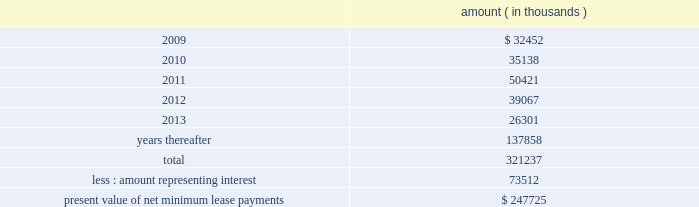Entergy corporation and subsidiaries notes to financial statements computed on a rolling 12 month basis .
As of december 31 , 2008 , entergy louisiana was in compliance with these provisions .
As of december 31 , 2008 , entergy louisiana had future minimum lease payments ( reflecting an overall implicit rate of 7.45% ( 7.45 % ) ) in connection with the waterford 3 sale and leaseback transactions , which are recorded as long-term debt , as follows : amount ( in thousands ) .
Grand gulf lease obligations in december 1988 , in two separate but substantially identical transactions , system energy sold and leased back undivided ownership interests in grand gulf for the aggregate sum of $ 500 million .
The interests represent approximately 11.5% ( 11.5 % ) of grand gulf .
The leases expire in 2015 .
Under certain circumstances , system entergy may repurchase the leased interests prior to the end of the term of the leases .
At the end of the lease terms , system energy has the option to repurchase the leased interests in grand gulf at fair market value or to renew the leases for either fair market value or , under certain conditions , a fixed rate .
In may 2004 , system energy caused the grand gulf lessors to refinance the outstanding bonds that they had issued to finance the purchase of their undivided interest in grand gulf .
The refinancing is at a lower interest rate , and system energy's lease payments have been reduced to reflect the lower interest costs .
System energy is required to report the sale-leaseback as a financing transaction in its financial statements .
For financial reporting purposes , system energy expenses the interest portion of the lease obligation and the plant depreciation .
However , operating revenues include the recovery of the lease payments because the transactions are accounted for as a sale and leaseback for ratemaking purposes .
Consistent with a recommendation contained in a ferc audit report , system energy initially recorded as a net regulatory asset the difference between the recovery of the lease payments and the amounts expensed for interest and depreciation and continues to record this difference as a regulatory asset or liability on an ongoing basis , resulting in a zero net balance for the regulatory asset at the end of the lease term .
The amount of this net regulatory asset was $ 19.2 million and $ 36.6 million as of december 31 , 2008 and 2007 , respectively. .
What is the growth rate in the net regulatory asset in 2008 compare 2007? 
Computations: ((19.2 - 36.6) / 36.6)
Answer: -0.47541. 